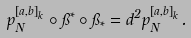<formula> <loc_0><loc_0><loc_500><loc_500>p _ { N } ^ { [ a , b ] _ { k } } \circ \pi ^ { * } \circ \pi _ { * } = d ^ { 2 } p _ { N } ^ { [ a , b ] _ { k } } .</formula> 